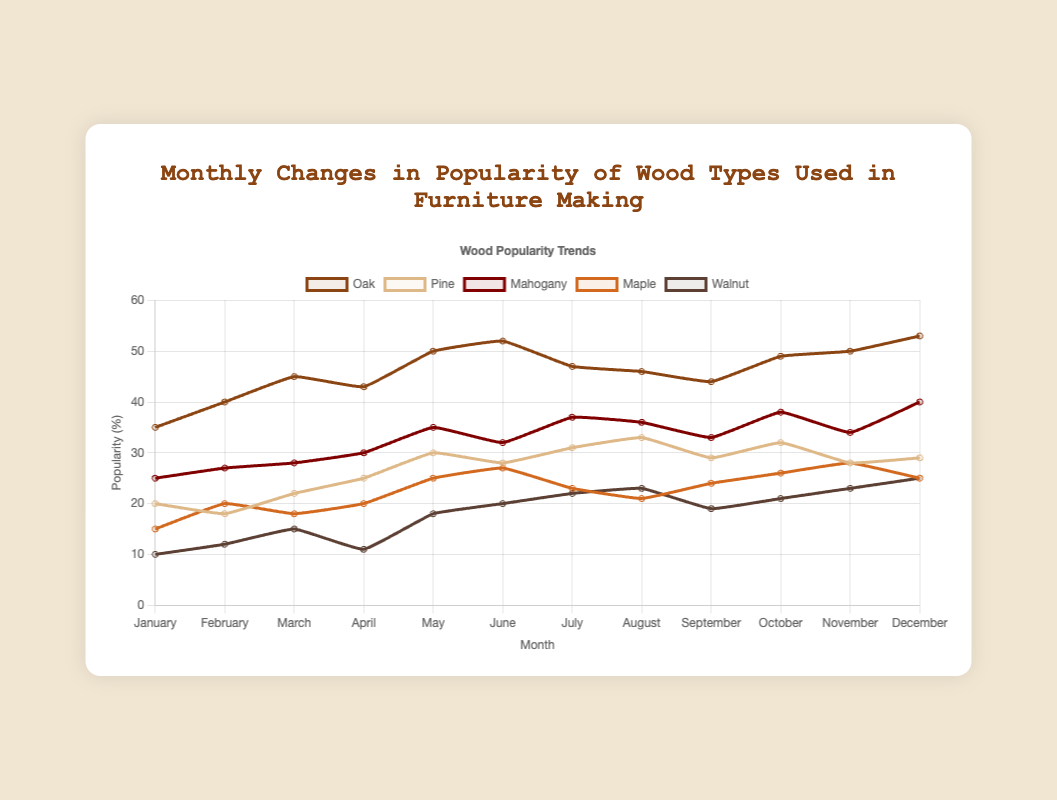Which month had the highest popularity for Oak? Look for the highest point on the Oak line (brown) on the graph. December has the highest value at 53%.
Answer: December How much did the popularity of Pine change from August to September? Identify the values for Pine in August (33%) and September (29%), then subtract the September value from the August value (33 - 29 = 4).
Answer: 4% Which wood type showed the greatest increase in popularity from May to June? Compare the values for each wood type between May and June: Oak (50 to 52, +2), Pine (30 to 28, -2), Mahogany (35 to 32, -3), Maple (25 to 27, +2), Walnut (18 to 20, +2). The greatest increase is from Oak, Maple, and Walnut each increasing by 2.
Answer: Oak, Maple, Walnut Which month had the lowest popularity for Walnut? Look for the lowest point on the Walnut line (dark brown) on the graph. January has the lowest value at 10%.
Answer: January What is the average popularity of Mahogany over the year? Add up the monthly popularity values for Mahogany: (25 + 27 + 28 + 30 + 35 + 32 + 37 + 36 + 33 + 38 + 34 + 40 = 395) and divide by the number of months (12). The average is 395/12 ≈ 32.92.
Answer: 32.92 Comparing April and October, which wood type showed the greatest percentage point increase? Compare the values for each wood type between April and October: Oak (43 to 49, +6), Pine (25 to 32, +7), Mahogany (30 to 38, +8), Maple (20 to 26, +6), Walnut (11 to 21, +10). The greatest increase is in Walnut with +10.
Answer: Walnut During which month did Oak and Mahogany have equal popularity? Identify the point where Oak and Mahogany lines intersect. This occurs in July where both have a value of 37%.
Answer: July What was the total popularity of all wood types in December? Sum the popularity of Oak, Pine, Mahogany, Maple, and Walnut in December: (53 + 29 + 40 + 25 + 25 = 172).
Answer: 172 How did the popularity of Maple change from February to March? Identify the values for Maple in February (20%) and March (18%), then subtract the March value from the February value (20 - 18 = -2).
Answer: -2 If you add the popularity of Maple and Walnut in the month of June, what will be the value? Identify the values for Maple (27%) and Walnut (20%) in June and sum them (27 + 20 = 47).
Answer: 47 